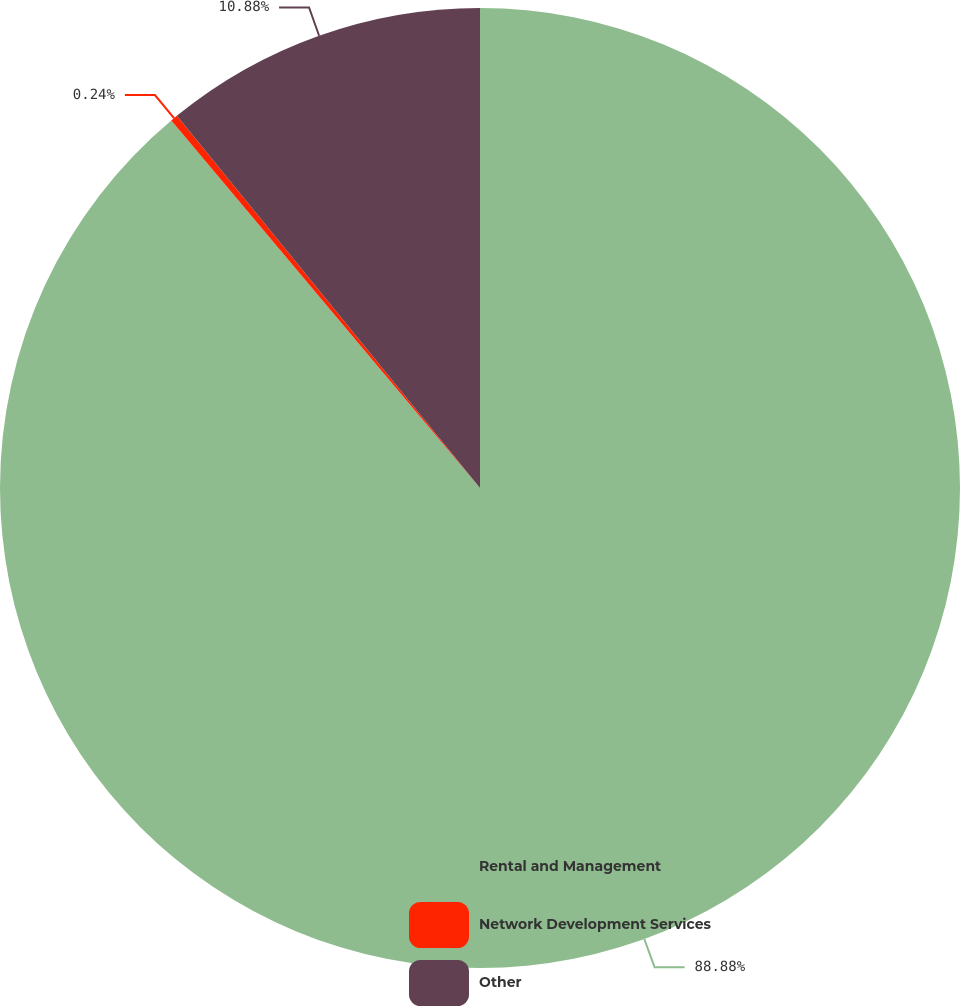<chart> <loc_0><loc_0><loc_500><loc_500><pie_chart><fcel>Rental and Management<fcel>Network Development Services<fcel>Other<nl><fcel>88.88%<fcel>0.24%<fcel>10.88%<nl></chart> 